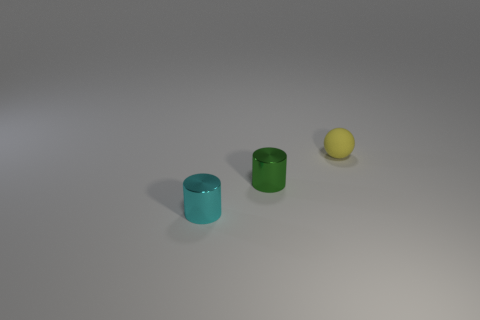Add 1 large purple shiny blocks. How many objects exist? 4 Add 1 tiny spheres. How many tiny spheres are left? 2 Add 1 large blue shiny objects. How many large blue shiny objects exist? 1 Subtract 0 gray blocks. How many objects are left? 3 Subtract all balls. How many objects are left? 2 Subtract 1 balls. How many balls are left? 0 Subtract all purple cylinders. Subtract all red cubes. How many cylinders are left? 2 Subtract all yellow spheres. How many green cylinders are left? 1 Subtract all small shiny cylinders. Subtract all big cyan rubber cubes. How many objects are left? 1 